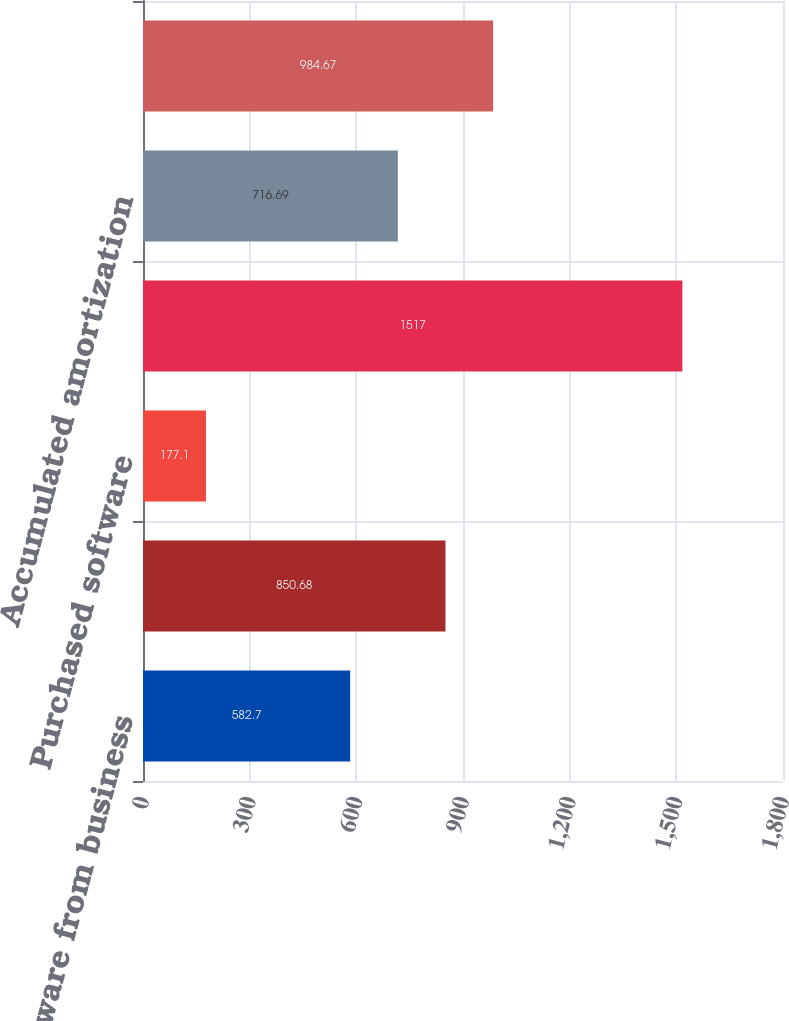Convert chart. <chart><loc_0><loc_0><loc_500><loc_500><bar_chart><fcel>Software from business<fcel>Capitalized software<fcel>Purchased software<fcel>Computer software<fcel>Accumulated amortization<fcel>Computer software net of<nl><fcel>582.7<fcel>850.68<fcel>177.1<fcel>1517<fcel>716.69<fcel>984.67<nl></chart> 